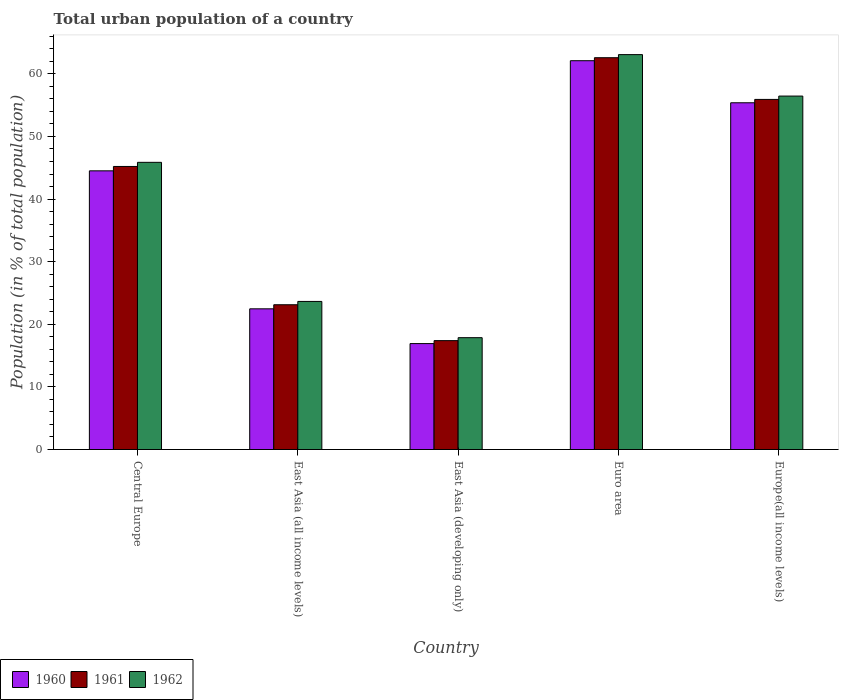How many groups of bars are there?
Make the answer very short. 5. What is the label of the 2nd group of bars from the left?
Offer a terse response. East Asia (all income levels). What is the urban population in 1962 in Central Europe?
Your answer should be compact. 45.87. Across all countries, what is the maximum urban population in 1960?
Provide a short and direct response. 62.1. Across all countries, what is the minimum urban population in 1962?
Your answer should be very brief. 17.86. In which country was the urban population in 1962 maximum?
Keep it short and to the point. Euro area. In which country was the urban population in 1960 minimum?
Provide a succinct answer. East Asia (developing only). What is the total urban population in 1962 in the graph?
Provide a short and direct response. 206.9. What is the difference between the urban population in 1961 in East Asia (all income levels) and that in East Asia (developing only)?
Your response must be concise. 5.73. What is the difference between the urban population in 1960 in East Asia (all income levels) and the urban population in 1961 in East Asia (developing only)?
Your response must be concise. 5.08. What is the average urban population in 1960 per country?
Offer a very short reply. 40.27. What is the difference between the urban population of/in 1961 and urban population of/in 1960 in Euro area?
Make the answer very short. 0.48. In how many countries, is the urban population in 1961 greater than 16 %?
Provide a succinct answer. 5. What is the ratio of the urban population in 1962 in East Asia (all income levels) to that in Europe(all income levels)?
Keep it short and to the point. 0.42. Is the difference between the urban population in 1961 in Central Europe and East Asia (all income levels) greater than the difference between the urban population in 1960 in Central Europe and East Asia (all income levels)?
Ensure brevity in your answer.  Yes. What is the difference between the highest and the second highest urban population in 1960?
Provide a short and direct response. -17.59. What is the difference between the highest and the lowest urban population in 1962?
Give a very brief answer. 45.21. Is the sum of the urban population in 1962 in Euro area and Europe(all income levels) greater than the maximum urban population in 1960 across all countries?
Offer a terse response. Yes. How many bars are there?
Provide a short and direct response. 15. Are all the bars in the graph horizontal?
Your answer should be compact. No. How many countries are there in the graph?
Ensure brevity in your answer.  5. Are the values on the major ticks of Y-axis written in scientific E-notation?
Offer a terse response. No. Does the graph contain any zero values?
Give a very brief answer. No. Where does the legend appear in the graph?
Offer a very short reply. Bottom left. How many legend labels are there?
Keep it short and to the point. 3. What is the title of the graph?
Make the answer very short. Total urban population of a country. What is the label or title of the X-axis?
Keep it short and to the point. Country. What is the label or title of the Y-axis?
Make the answer very short. Population (in % of total population). What is the Population (in % of total population) of 1960 in Central Europe?
Keep it short and to the point. 44.51. What is the Population (in % of total population) in 1961 in Central Europe?
Your response must be concise. 45.21. What is the Population (in % of total population) of 1962 in Central Europe?
Keep it short and to the point. 45.87. What is the Population (in % of total population) in 1960 in East Asia (all income levels)?
Your answer should be very brief. 22.47. What is the Population (in % of total population) in 1961 in East Asia (all income levels)?
Provide a succinct answer. 23.12. What is the Population (in % of total population) in 1962 in East Asia (all income levels)?
Make the answer very short. 23.65. What is the Population (in % of total population) of 1960 in East Asia (developing only)?
Your answer should be compact. 16.92. What is the Population (in % of total population) in 1961 in East Asia (developing only)?
Your answer should be very brief. 17.39. What is the Population (in % of total population) in 1962 in East Asia (developing only)?
Provide a short and direct response. 17.86. What is the Population (in % of total population) in 1960 in Euro area?
Keep it short and to the point. 62.1. What is the Population (in % of total population) of 1961 in Euro area?
Your response must be concise. 62.58. What is the Population (in % of total population) in 1962 in Euro area?
Your answer should be very brief. 63.07. What is the Population (in % of total population) of 1960 in Europe(all income levels)?
Your response must be concise. 55.38. What is the Population (in % of total population) of 1961 in Europe(all income levels)?
Ensure brevity in your answer.  55.92. What is the Population (in % of total population) in 1962 in Europe(all income levels)?
Provide a short and direct response. 56.45. Across all countries, what is the maximum Population (in % of total population) of 1960?
Offer a terse response. 62.1. Across all countries, what is the maximum Population (in % of total population) in 1961?
Your response must be concise. 62.58. Across all countries, what is the maximum Population (in % of total population) of 1962?
Make the answer very short. 63.07. Across all countries, what is the minimum Population (in % of total population) in 1960?
Provide a succinct answer. 16.92. Across all countries, what is the minimum Population (in % of total population) of 1961?
Your response must be concise. 17.39. Across all countries, what is the minimum Population (in % of total population) of 1962?
Provide a succinct answer. 17.86. What is the total Population (in % of total population) in 1960 in the graph?
Your answer should be compact. 201.37. What is the total Population (in % of total population) of 1961 in the graph?
Provide a succinct answer. 204.21. What is the total Population (in % of total population) of 1962 in the graph?
Provide a succinct answer. 206.9. What is the difference between the Population (in % of total population) in 1960 in Central Europe and that in East Asia (all income levels)?
Make the answer very short. 22.04. What is the difference between the Population (in % of total population) in 1961 in Central Europe and that in East Asia (all income levels)?
Keep it short and to the point. 22.08. What is the difference between the Population (in % of total population) in 1962 in Central Europe and that in East Asia (all income levels)?
Provide a short and direct response. 22.22. What is the difference between the Population (in % of total population) of 1960 in Central Europe and that in East Asia (developing only)?
Provide a short and direct response. 27.59. What is the difference between the Population (in % of total population) of 1961 in Central Europe and that in East Asia (developing only)?
Provide a short and direct response. 27.82. What is the difference between the Population (in % of total population) in 1962 in Central Europe and that in East Asia (developing only)?
Your answer should be very brief. 28. What is the difference between the Population (in % of total population) in 1960 in Central Europe and that in Euro area?
Offer a very short reply. -17.59. What is the difference between the Population (in % of total population) in 1961 in Central Europe and that in Euro area?
Make the answer very short. -17.37. What is the difference between the Population (in % of total population) of 1962 in Central Europe and that in Euro area?
Provide a short and direct response. -17.2. What is the difference between the Population (in % of total population) in 1960 in Central Europe and that in Europe(all income levels)?
Provide a succinct answer. -10.87. What is the difference between the Population (in % of total population) in 1961 in Central Europe and that in Europe(all income levels)?
Keep it short and to the point. -10.71. What is the difference between the Population (in % of total population) of 1962 in Central Europe and that in Europe(all income levels)?
Provide a short and direct response. -10.58. What is the difference between the Population (in % of total population) in 1960 in East Asia (all income levels) and that in East Asia (developing only)?
Ensure brevity in your answer.  5.55. What is the difference between the Population (in % of total population) in 1961 in East Asia (all income levels) and that in East Asia (developing only)?
Your answer should be compact. 5.73. What is the difference between the Population (in % of total population) in 1962 in East Asia (all income levels) and that in East Asia (developing only)?
Provide a short and direct response. 5.79. What is the difference between the Population (in % of total population) of 1960 in East Asia (all income levels) and that in Euro area?
Make the answer very short. -39.63. What is the difference between the Population (in % of total population) of 1961 in East Asia (all income levels) and that in Euro area?
Give a very brief answer. -39.45. What is the difference between the Population (in % of total population) in 1962 in East Asia (all income levels) and that in Euro area?
Provide a short and direct response. -39.42. What is the difference between the Population (in % of total population) of 1960 in East Asia (all income levels) and that in Europe(all income levels)?
Provide a short and direct response. -32.91. What is the difference between the Population (in % of total population) of 1961 in East Asia (all income levels) and that in Europe(all income levels)?
Offer a very short reply. -32.79. What is the difference between the Population (in % of total population) in 1962 in East Asia (all income levels) and that in Europe(all income levels)?
Make the answer very short. -32.8. What is the difference between the Population (in % of total population) in 1960 in East Asia (developing only) and that in Euro area?
Make the answer very short. -45.18. What is the difference between the Population (in % of total population) in 1961 in East Asia (developing only) and that in Euro area?
Make the answer very short. -45.18. What is the difference between the Population (in % of total population) of 1962 in East Asia (developing only) and that in Euro area?
Offer a very short reply. -45.21. What is the difference between the Population (in % of total population) in 1960 in East Asia (developing only) and that in Europe(all income levels)?
Ensure brevity in your answer.  -38.46. What is the difference between the Population (in % of total population) in 1961 in East Asia (developing only) and that in Europe(all income levels)?
Keep it short and to the point. -38.52. What is the difference between the Population (in % of total population) of 1962 in East Asia (developing only) and that in Europe(all income levels)?
Your response must be concise. -38.59. What is the difference between the Population (in % of total population) in 1960 in Euro area and that in Europe(all income levels)?
Your answer should be compact. 6.72. What is the difference between the Population (in % of total population) of 1961 in Euro area and that in Europe(all income levels)?
Make the answer very short. 6.66. What is the difference between the Population (in % of total population) in 1962 in Euro area and that in Europe(all income levels)?
Your answer should be very brief. 6.62. What is the difference between the Population (in % of total population) in 1960 in Central Europe and the Population (in % of total population) in 1961 in East Asia (all income levels)?
Offer a terse response. 21.39. What is the difference between the Population (in % of total population) of 1960 in Central Europe and the Population (in % of total population) of 1962 in East Asia (all income levels)?
Your response must be concise. 20.86. What is the difference between the Population (in % of total population) in 1961 in Central Europe and the Population (in % of total population) in 1962 in East Asia (all income levels)?
Provide a succinct answer. 21.56. What is the difference between the Population (in % of total population) of 1960 in Central Europe and the Population (in % of total population) of 1961 in East Asia (developing only)?
Your response must be concise. 27.12. What is the difference between the Population (in % of total population) in 1960 in Central Europe and the Population (in % of total population) in 1962 in East Asia (developing only)?
Make the answer very short. 26.65. What is the difference between the Population (in % of total population) in 1961 in Central Europe and the Population (in % of total population) in 1962 in East Asia (developing only)?
Provide a succinct answer. 27.34. What is the difference between the Population (in % of total population) in 1960 in Central Europe and the Population (in % of total population) in 1961 in Euro area?
Offer a very short reply. -18.07. What is the difference between the Population (in % of total population) of 1960 in Central Europe and the Population (in % of total population) of 1962 in Euro area?
Ensure brevity in your answer.  -18.56. What is the difference between the Population (in % of total population) of 1961 in Central Europe and the Population (in % of total population) of 1962 in Euro area?
Offer a terse response. -17.86. What is the difference between the Population (in % of total population) in 1960 in Central Europe and the Population (in % of total population) in 1961 in Europe(all income levels)?
Provide a short and direct response. -11.41. What is the difference between the Population (in % of total population) in 1960 in Central Europe and the Population (in % of total population) in 1962 in Europe(all income levels)?
Ensure brevity in your answer.  -11.94. What is the difference between the Population (in % of total population) in 1961 in Central Europe and the Population (in % of total population) in 1962 in Europe(all income levels)?
Provide a short and direct response. -11.24. What is the difference between the Population (in % of total population) in 1960 in East Asia (all income levels) and the Population (in % of total population) in 1961 in East Asia (developing only)?
Your answer should be very brief. 5.08. What is the difference between the Population (in % of total population) in 1960 in East Asia (all income levels) and the Population (in % of total population) in 1962 in East Asia (developing only)?
Your answer should be compact. 4.61. What is the difference between the Population (in % of total population) in 1961 in East Asia (all income levels) and the Population (in % of total population) in 1962 in East Asia (developing only)?
Ensure brevity in your answer.  5.26. What is the difference between the Population (in % of total population) in 1960 in East Asia (all income levels) and the Population (in % of total population) in 1961 in Euro area?
Your response must be concise. -40.1. What is the difference between the Population (in % of total population) in 1960 in East Asia (all income levels) and the Population (in % of total population) in 1962 in Euro area?
Provide a short and direct response. -40.6. What is the difference between the Population (in % of total population) in 1961 in East Asia (all income levels) and the Population (in % of total population) in 1962 in Euro area?
Your answer should be compact. -39.95. What is the difference between the Population (in % of total population) in 1960 in East Asia (all income levels) and the Population (in % of total population) in 1961 in Europe(all income levels)?
Offer a terse response. -33.44. What is the difference between the Population (in % of total population) of 1960 in East Asia (all income levels) and the Population (in % of total population) of 1962 in Europe(all income levels)?
Keep it short and to the point. -33.98. What is the difference between the Population (in % of total population) in 1961 in East Asia (all income levels) and the Population (in % of total population) in 1962 in Europe(all income levels)?
Provide a short and direct response. -33.33. What is the difference between the Population (in % of total population) of 1960 in East Asia (developing only) and the Population (in % of total population) of 1961 in Euro area?
Your response must be concise. -45.66. What is the difference between the Population (in % of total population) in 1960 in East Asia (developing only) and the Population (in % of total population) in 1962 in Euro area?
Ensure brevity in your answer.  -46.15. What is the difference between the Population (in % of total population) of 1961 in East Asia (developing only) and the Population (in % of total population) of 1962 in Euro area?
Keep it short and to the point. -45.68. What is the difference between the Population (in % of total population) in 1960 in East Asia (developing only) and the Population (in % of total population) in 1961 in Europe(all income levels)?
Give a very brief answer. -39. What is the difference between the Population (in % of total population) in 1960 in East Asia (developing only) and the Population (in % of total population) in 1962 in Europe(all income levels)?
Offer a terse response. -39.53. What is the difference between the Population (in % of total population) in 1961 in East Asia (developing only) and the Population (in % of total population) in 1962 in Europe(all income levels)?
Keep it short and to the point. -39.06. What is the difference between the Population (in % of total population) of 1960 in Euro area and the Population (in % of total population) of 1961 in Europe(all income levels)?
Offer a very short reply. 6.18. What is the difference between the Population (in % of total population) in 1960 in Euro area and the Population (in % of total population) in 1962 in Europe(all income levels)?
Your answer should be very brief. 5.65. What is the difference between the Population (in % of total population) of 1961 in Euro area and the Population (in % of total population) of 1962 in Europe(all income levels)?
Ensure brevity in your answer.  6.13. What is the average Population (in % of total population) of 1960 per country?
Provide a short and direct response. 40.27. What is the average Population (in % of total population) in 1961 per country?
Provide a short and direct response. 40.84. What is the average Population (in % of total population) in 1962 per country?
Your answer should be compact. 41.38. What is the difference between the Population (in % of total population) in 1960 and Population (in % of total population) in 1961 in Central Europe?
Give a very brief answer. -0.7. What is the difference between the Population (in % of total population) of 1960 and Population (in % of total population) of 1962 in Central Europe?
Provide a succinct answer. -1.36. What is the difference between the Population (in % of total population) of 1961 and Population (in % of total population) of 1962 in Central Europe?
Ensure brevity in your answer.  -0.66. What is the difference between the Population (in % of total population) of 1960 and Population (in % of total population) of 1961 in East Asia (all income levels)?
Offer a very short reply. -0.65. What is the difference between the Population (in % of total population) in 1960 and Population (in % of total population) in 1962 in East Asia (all income levels)?
Your answer should be very brief. -1.18. What is the difference between the Population (in % of total population) of 1961 and Population (in % of total population) of 1962 in East Asia (all income levels)?
Make the answer very short. -0.53. What is the difference between the Population (in % of total population) in 1960 and Population (in % of total population) in 1961 in East Asia (developing only)?
Your response must be concise. -0.47. What is the difference between the Population (in % of total population) of 1960 and Population (in % of total population) of 1962 in East Asia (developing only)?
Your answer should be very brief. -0.95. What is the difference between the Population (in % of total population) in 1961 and Population (in % of total population) in 1962 in East Asia (developing only)?
Provide a short and direct response. -0.47. What is the difference between the Population (in % of total population) in 1960 and Population (in % of total population) in 1961 in Euro area?
Give a very brief answer. -0.48. What is the difference between the Population (in % of total population) in 1960 and Population (in % of total population) in 1962 in Euro area?
Provide a short and direct response. -0.97. What is the difference between the Population (in % of total population) in 1961 and Population (in % of total population) in 1962 in Euro area?
Your answer should be very brief. -0.49. What is the difference between the Population (in % of total population) in 1960 and Population (in % of total population) in 1961 in Europe(all income levels)?
Ensure brevity in your answer.  -0.54. What is the difference between the Population (in % of total population) in 1960 and Population (in % of total population) in 1962 in Europe(all income levels)?
Your answer should be compact. -1.07. What is the difference between the Population (in % of total population) of 1961 and Population (in % of total population) of 1962 in Europe(all income levels)?
Your answer should be very brief. -0.53. What is the ratio of the Population (in % of total population) of 1960 in Central Europe to that in East Asia (all income levels)?
Ensure brevity in your answer.  1.98. What is the ratio of the Population (in % of total population) in 1961 in Central Europe to that in East Asia (all income levels)?
Your answer should be very brief. 1.96. What is the ratio of the Population (in % of total population) in 1962 in Central Europe to that in East Asia (all income levels)?
Keep it short and to the point. 1.94. What is the ratio of the Population (in % of total population) of 1960 in Central Europe to that in East Asia (developing only)?
Offer a terse response. 2.63. What is the ratio of the Population (in % of total population) of 1961 in Central Europe to that in East Asia (developing only)?
Give a very brief answer. 2.6. What is the ratio of the Population (in % of total population) in 1962 in Central Europe to that in East Asia (developing only)?
Your response must be concise. 2.57. What is the ratio of the Population (in % of total population) in 1960 in Central Europe to that in Euro area?
Provide a succinct answer. 0.72. What is the ratio of the Population (in % of total population) in 1961 in Central Europe to that in Euro area?
Give a very brief answer. 0.72. What is the ratio of the Population (in % of total population) in 1962 in Central Europe to that in Euro area?
Give a very brief answer. 0.73. What is the ratio of the Population (in % of total population) of 1960 in Central Europe to that in Europe(all income levels)?
Ensure brevity in your answer.  0.8. What is the ratio of the Population (in % of total population) of 1961 in Central Europe to that in Europe(all income levels)?
Ensure brevity in your answer.  0.81. What is the ratio of the Population (in % of total population) of 1962 in Central Europe to that in Europe(all income levels)?
Give a very brief answer. 0.81. What is the ratio of the Population (in % of total population) of 1960 in East Asia (all income levels) to that in East Asia (developing only)?
Give a very brief answer. 1.33. What is the ratio of the Population (in % of total population) of 1961 in East Asia (all income levels) to that in East Asia (developing only)?
Your answer should be compact. 1.33. What is the ratio of the Population (in % of total population) of 1962 in East Asia (all income levels) to that in East Asia (developing only)?
Your response must be concise. 1.32. What is the ratio of the Population (in % of total population) of 1960 in East Asia (all income levels) to that in Euro area?
Your response must be concise. 0.36. What is the ratio of the Population (in % of total population) of 1961 in East Asia (all income levels) to that in Euro area?
Offer a very short reply. 0.37. What is the ratio of the Population (in % of total population) in 1962 in East Asia (all income levels) to that in Euro area?
Offer a terse response. 0.38. What is the ratio of the Population (in % of total population) of 1960 in East Asia (all income levels) to that in Europe(all income levels)?
Ensure brevity in your answer.  0.41. What is the ratio of the Population (in % of total population) in 1961 in East Asia (all income levels) to that in Europe(all income levels)?
Provide a succinct answer. 0.41. What is the ratio of the Population (in % of total population) of 1962 in East Asia (all income levels) to that in Europe(all income levels)?
Provide a short and direct response. 0.42. What is the ratio of the Population (in % of total population) in 1960 in East Asia (developing only) to that in Euro area?
Give a very brief answer. 0.27. What is the ratio of the Population (in % of total population) of 1961 in East Asia (developing only) to that in Euro area?
Offer a terse response. 0.28. What is the ratio of the Population (in % of total population) of 1962 in East Asia (developing only) to that in Euro area?
Your answer should be very brief. 0.28. What is the ratio of the Population (in % of total population) of 1960 in East Asia (developing only) to that in Europe(all income levels)?
Your response must be concise. 0.31. What is the ratio of the Population (in % of total population) in 1961 in East Asia (developing only) to that in Europe(all income levels)?
Make the answer very short. 0.31. What is the ratio of the Population (in % of total population) of 1962 in East Asia (developing only) to that in Europe(all income levels)?
Your answer should be compact. 0.32. What is the ratio of the Population (in % of total population) of 1960 in Euro area to that in Europe(all income levels)?
Provide a succinct answer. 1.12. What is the ratio of the Population (in % of total population) in 1961 in Euro area to that in Europe(all income levels)?
Ensure brevity in your answer.  1.12. What is the ratio of the Population (in % of total population) in 1962 in Euro area to that in Europe(all income levels)?
Offer a terse response. 1.12. What is the difference between the highest and the second highest Population (in % of total population) in 1960?
Your response must be concise. 6.72. What is the difference between the highest and the second highest Population (in % of total population) in 1961?
Offer a very short reply. 6.66. What is the difference between the highest and the second highest Population (in % of total population) in 1962?
Provide a succinct answer. 6.62. What is the difference between the highest and the lowest Population (in % of total population) of 1960?
Offer a very short reply. 45.18. What is the difference between the highest and the lowest Population (in % of total population) of 1961?
Your answer should be compact. 45.18. What is the difference between the highest and the lowest Population (in % of total population) of 1962?
Offer a terse response. 45.21. 